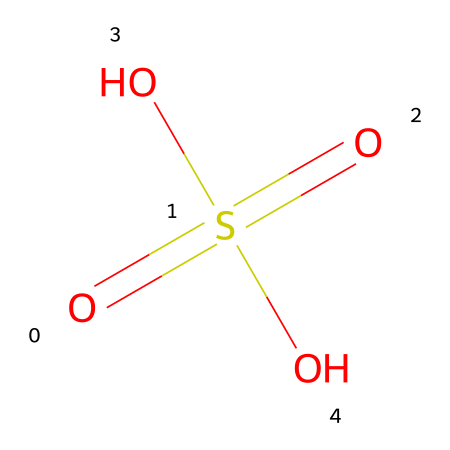What is the chemical name of this compound? The visual structure corresponds to the well-known compound that consists of two sulfate groups and two hydroxyl groups, which is commonly recognized as sulfuric acid.
Answer: sulfuric acid How many oxygen atoms are present in the molecule? By analyzing the structure, we see that there are four oxygen atoms attached to the sulfur atom and the hydroxyl groups.
Answer: 4 What is the central atom in this molecule? Observing the SMILES representation shows that the sulfur atom is at the core, as it defines the compound and has multiple bonds to oxygen atoms.
Answer: sulfur How many double bonds are there in the molecule? The structure exhibits two double bonds between the sulfur atom and two of the oxygen atoms, indicating a total of two double bonds.
Answer: 2 What type of acid is sulfuric acid classified as? Given that sulfuric acid is known for its strong ability to donate protons in aqueous solutions, it is classified as a strong acid.
Answer: strong acid What functional groups are present in sulfuric acid? The presence of hydroxyl (–OH) and sulfonic (–SO3) groups, along with double-bonded oxygen, indicates the functional groups in this chemical.
Answer: hydroxyl and sulfonic groups 